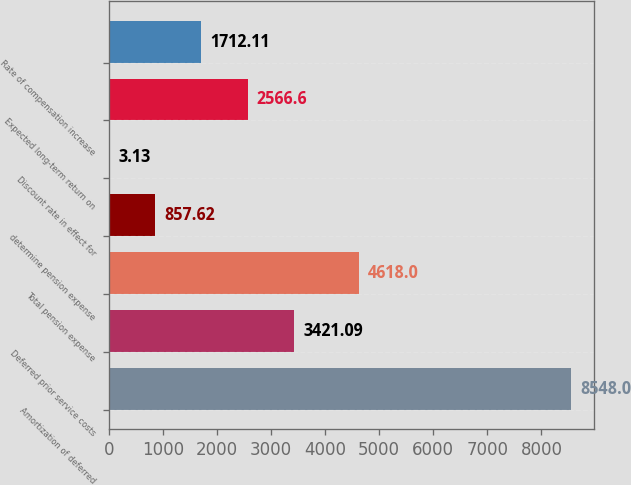Convert chart. <chart><loc_0><loc_0><loc_500><loc_500><bar_chart><fcel>Amortization of deferred<fcel>Deferred prior service costs<fcel>Total pension expense<fcel>determine pension expense<fcel>Discount rate in effect for<fcel>Expected long-term return on<fcel>Rate of compensation increase<nl><fcel>8548<fcel>3421.09<fcel>4618<fcel>857.62<fcel>3.13<fcel>2566.6<fcel>1712.11<nl></chart> 